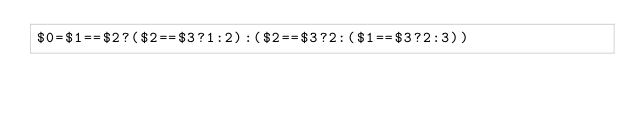<code> <loc_0><loc_0><loc_500><loc_500><_Awk_>$0=$1==$2?($2==$3?1:2):($2==$3?2:($1==$3?2:3))</code> 